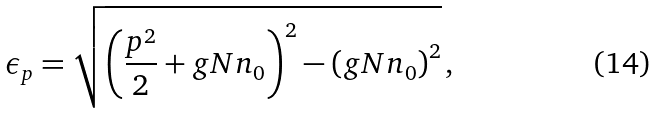Convert formula to latex. <formula><loc_0><loc_0><loc_500><loc_500>\epsilon _ { p } = \sqrt { \left ( \frac { p ^ { 2 } } { 2 } + g N n _ { 0 } \right ) ^ { 2 } - \left ( g N n _ { 0 } \right ) ^ { 2 } } \, ,</formula> 